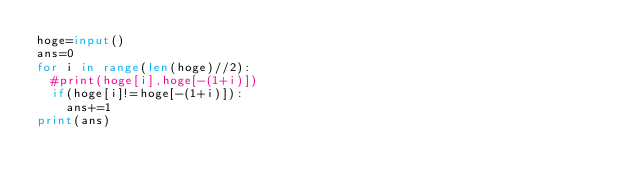Convert code to text. <code><loc_0><loc_0><loc_500><loc_500><_Python_>hoge=input()
ans=0
for i in range(len(hoge)//2):
  #print(hoge[i],hoge[-(1+i)])
  if(hoge[i]!=hoge[-(1+i)]):
    ans+=1
print(ans)</code> 